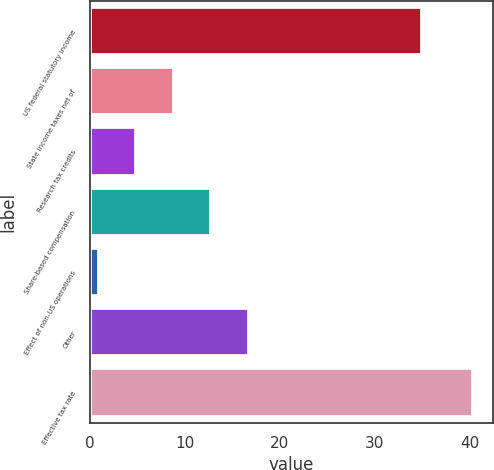<chart> <loc_0><loc_0><loc_500><loc_500><bar_chart><fcel>US federal statutory income<fcel>State income taxes net of<fcel>Research tax credits<fcel>Share-based compensation<fcel>Effect of non-US operations<fcel>Other<fcel>Effective tax rate<nl><fcel>35<fcel>8.8<fcel>4.85<fcel>12.75<fcel>0.9<fcel>16.7<fcel>40.4<nl></chart> 